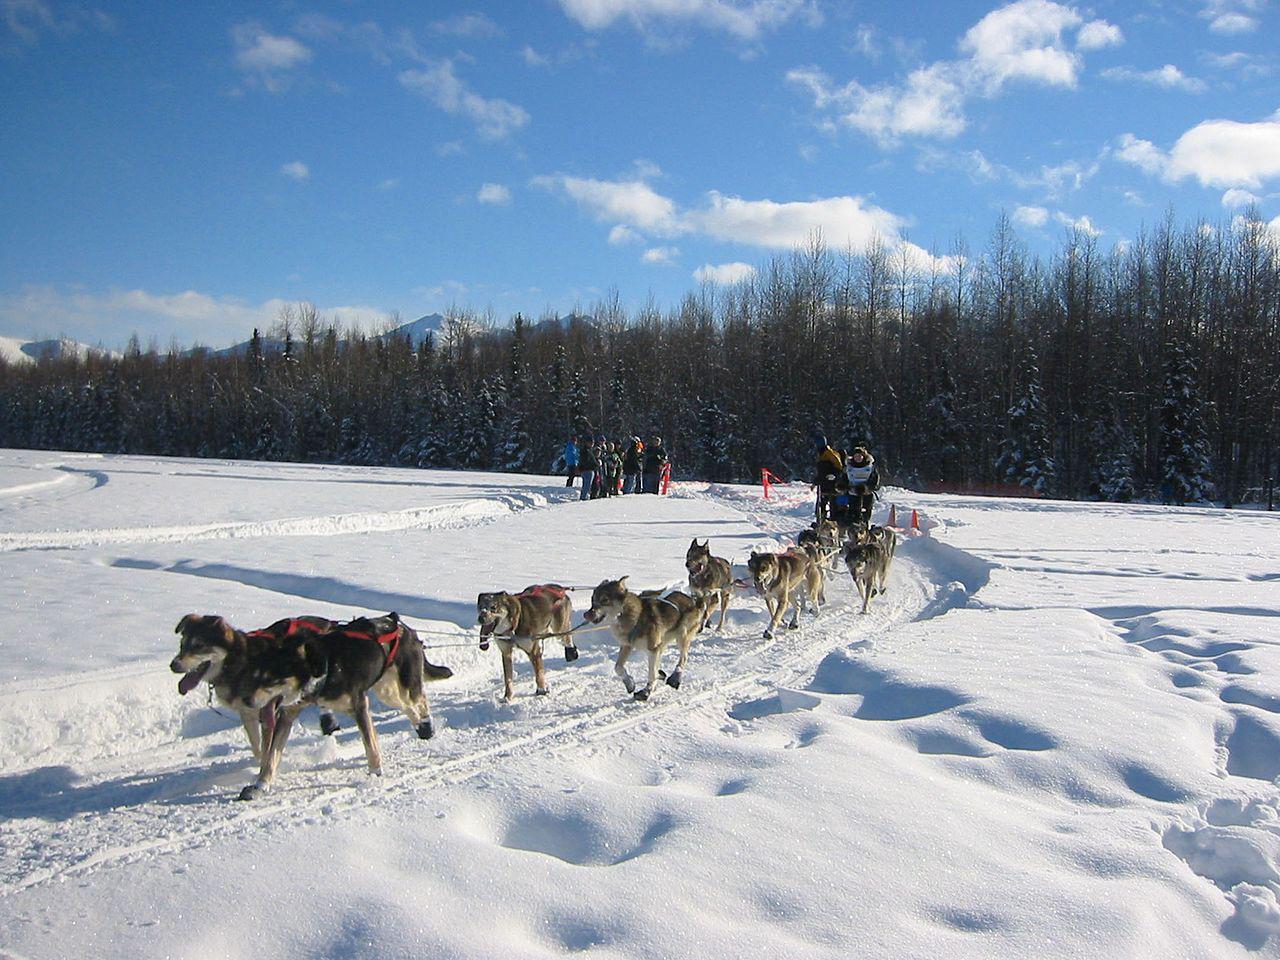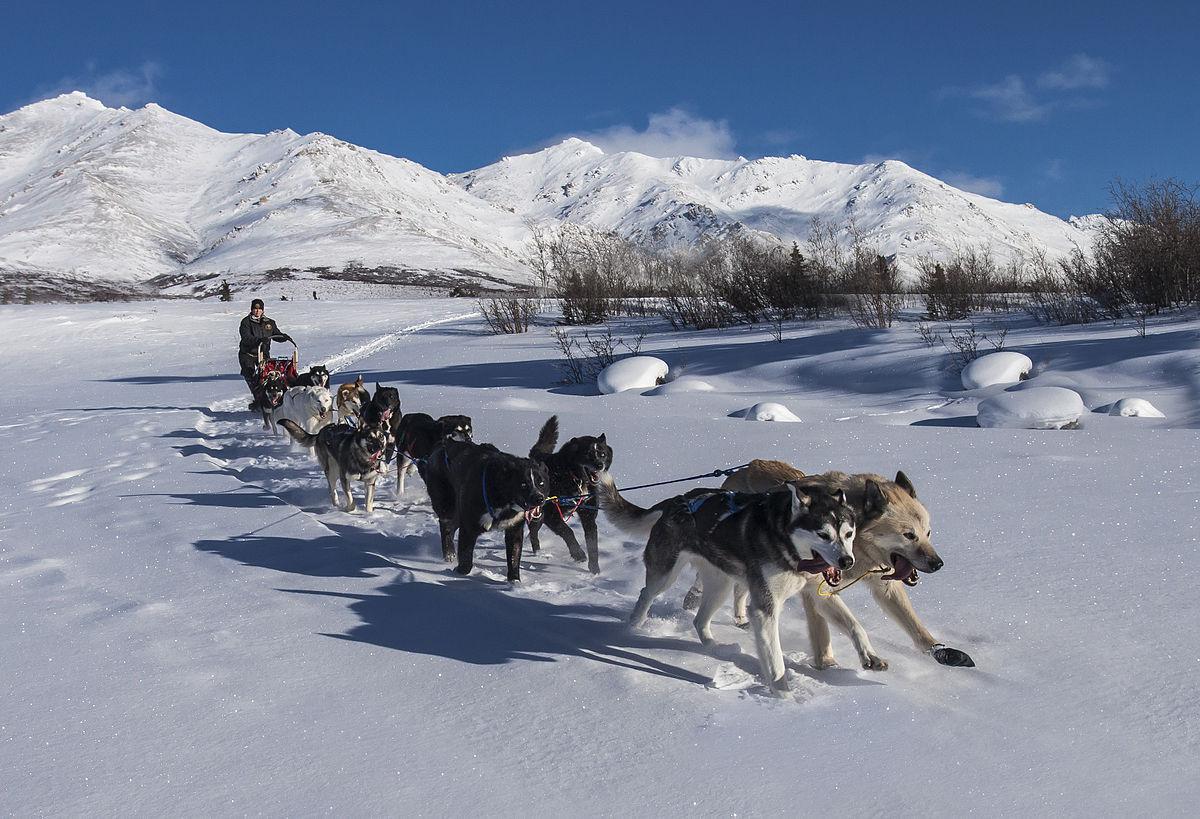The first image is the image on the left, the second image is the image on the right. Assess this claim about the two images: "Mountains are visible behind the sled dogs". Correct or not? Answer yes or no. Yes. The first image is the image on the left, the second image is the image on the right. Analyze the images presented: Is the assertion "Right image shows sled dogs moving rightward, with a mountain backdrop." valid? Answer yes or no. Yes. 